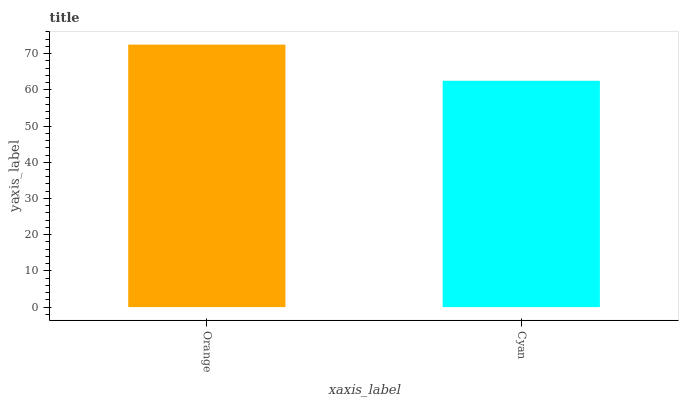Is Cyan the minimum?
Answer yes or no. Yes. Is Orange the maximum?
Answer yes or no. Yes. Is Cyan the maximum?
Answer yes or no. No. Is Orange greater than Cyan?
Answer yes or no. Yes. Is Cyan less than Orange?
Answer yes or no. Yes. Is Cyan greater than Orange?
Answer yes or no. No. Is Orange less than Cyan?
Answer yes or no. No. Is Orange the high median?
Answer yes or no. Yes. Is Cyan the low median?
Answer yes or no. Yes. Is Cyan the high median?
Answer yes or no. No. Is Orange the low median?
Answer yes or no. No. 